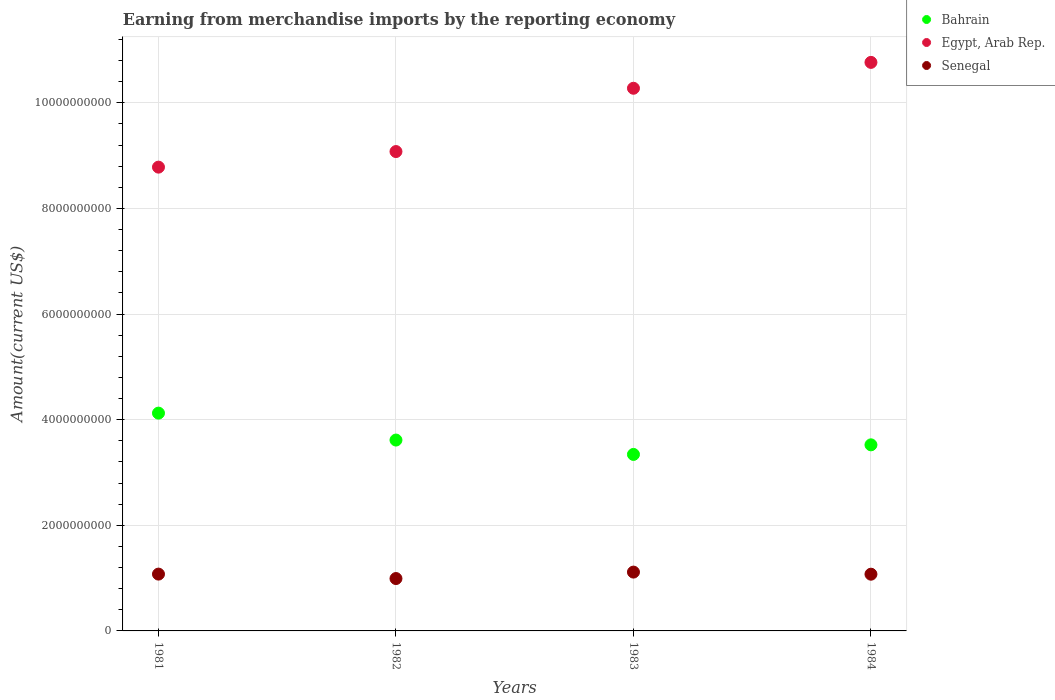Is the number of dotlines equal to the number of legend labels?
Offer a terse response. Yes. What is the amount earned from merchandise imports in Senegal in 1982?
Your answer should be very brief. 9.92e+08. Across all years, what is the maximum amount earned from merchandise imports in Bahrain?
Ensure brevity in your answer.  4.12e+09. Across all years, what is the minimum amount earned from merchandise imports in Egypt, Arab Rep.?
Make the answer very short. 8.78e+09. In which year was the amount earned from merchandise imports in Bahrain maximum?
Make the answer very short. 1981. What is the total amount earned from merchandise imports in Senegal in the graph?
Provide a short and direct response. 4.26e+09. What is the difference between the amount earned from merchandise imports in Egypt, Arab Rep. in 1981 and that in 1983?
Make the answer very short. -1.49e+09. What is the difference between the amount earned from merchandise imports in Bahrain in 1983 and the amount earned from merchandise imports in Senegal in 1982?
Your answer should be compact. 2.35e+09. What is the average amount earned from merchandise imports in Senegal per year?
Offer a very short reply. 1.06e+09. In the year 1983, what is the difference between the amount earned from merchandise imports in Senegal and amount earned from merchandise imports in Egypt, Arab Rep.?
Your answer should be very brief. -9.16e+09. What is the ratio of the amount earned from merchandise imports in Senegal in 1983 to that in 1984?
Your answer should be very brief. 1.04. What is the difference between the highest and the second highest amount earned from merchandise imports in Senegal?
Your response must be concise. 3.80e+07. What is the difference between the highest and the lowest amount earned from merchandise imports in Senegal?
Ensure brevity in your answer.  1.22e+08. In how many years, is the amount earned from merchandise imports in Egypt, Arab Rep. greater than the average amount earned from merchandise imports in Egypt, Arab Rep. taken over all years?
Ensure brevity in your answer.  2. Is the sum of the amount earned from merchandise imports in Egypt, Arab Rep. in 1982 and 1984 greater than the maximum amount earned from merchandise imports in Bahrain across all years?
Your answer should be compact. Yes. Does the amount earned from merchandise imports in Egypt, Arab Rep. monotonically increase over the years?
Give a very brief answer. Yes. Is the amount earned from merchandise imports in Bahrain strictly greater than the amount earned from merchandise imports in Egypt, Arab Rep. over the years?
Your answer should be compact. No. Is the amount earned from merchandise imports in Bahrain strictly less than the amount earned from merchandise imports in Senegal over the years?
Keep it short and to the point. No. How many years are there in the graph?
Give a very brief answer. 4. What is the difference between two consecutive major ticks on the Y-axis?
Your answer should be compact. 2.00e+09. Does the graph contain any zero values?
Your response must be concise. No. How are the legend labels stacked?
Offer a terse response. Vertical. What is the title of the graph?
Your response must be concise. Earning from merchandise imports by the reporting economy. What is the label or title of the Y-axis?
Your response must be concise. Amount(current US$). What is the Amount(current US$) of Bahrain in 1981?
Provide a succinct answer. 4.12e+09. What is the Amount(current US$) in Egypt, Arab Rep. in 1981?
Offer a terse response. 8.78e+09. What is the Amount(current US$) in Senegal in 1981?
Provide a short and direct response. 1.08e+09. What is the Amount(current US$) in Bahrain in 1982?
Provide a succinct answer. 3.61e+09. What is the Amount(current US$) in Egypt, Arab Rep. in 1982?
Ensure brevity in your answer.  9.08e+09. What is the Amount(current US$) of Senegal in 1982?
Offer a terse response. 9.92e+08. What is the Amount(current US$) of Bahrain in 1983?
Keep it short and to the point. 3.34e+09. What is the Amount(current US$) of Egypt, Arab Rep. in 1983?
Provide a short and direct response. 1.03e+1. What is the Amount(current US$) of Senegal in 1983?
Your response must be concise. 1.11e+09. What is the Amount(current US$) in Bahrain in 1984?
Give a very brief answer. 3.52e+09. What is the Amount(current US$) of Egypt, Arab Rep. in 1984?
Ensure brevity in your answer.  1.08e+1. What is the Amount(current US$) in Senegal in 1984?
Ensure brevity in your answer.  1.07e+09. Across all years, what is the maximum Amount(current US$) in Bahrain?
Ensure brevity in your answer.  4.12e+09. Across all years, what is the maximum Amount(current US$) of Egypt, Arab Rep.?
Make the answer very short. 1.08e+1. Across all years, what is the maximum Amount(current US$) in Senegal?
Offer a very short reply. 1.11e+09. Across all years, what is the minimum Amount(current US$) in Bahrain?
Give a very brief answer. 3.34e+09. Across all years, what is the minimum Amount(current US$) in Egypt, Arab Rep.?
Your answer should be compact. 8.78e+09. Across all years, what is the minimum Amount(current US$) of Senegal?
Your answer should be compact. 9.92e+08. What is the total Amount(current US$) of Bahrain in the graph?
Your response must be concise. 1.46e+1. What is the total Amount(current US$) of Egypt, Arab Rep. in the graph?
Offer a terse response. 3.89e+1. What is the total Amount(current US$) of Senegal in the graph?
Make the answer very short. 4.26e+09. What is the difference between the Amount(current US$) of Bahrain in 1981 and that in 1982?
Provide a succinct answer. 5.10e+08. What is the difference between the Amount(current US$) in Egypt, Arab Rep. in 1981 and that in 1982?
Your answer should be compact. -2.95e+08. What is the difference between the Amount(current US$) in Senegal in 1981 and that in 1982?
Offer a terse response. 8.40e+07. What is the difference between the Amount(current US$) of Bahrain in 1981 and that in 1983?
Make the answer very short. 7.82e+08. What is the difference between the Amount(current US$) of Egypt, Arab Rep. in 1981 and that in 1983?
Your answer should be very brief. -1.49e+09. What is the difference between the Amount(current US$) in Senegal in 1981 and that in 1983?
Offer a very short reply. -3.80e+07. What is the difference between the Amount(current US$) in Bahrain in 1981 and that in 1984?
Your response must be concise. 6.00e+08. What is the difference between the Amount(current US$) of Egypt, Arab Rep. in 1981 and that in 1984?
Your response must be concise. -1.98e+09. What is the difference between the Amount(current US$) in Senegal in 1981 and that in 1984?
Your answer should be compact. 1.67e+06. What is the difference between the Amount(current US$) in Bahrain in 1982 and that in 1983?
Make the answer very short. 2.72e+08. What is the difference between the Amount(current US$) of Egypt, Arab Rep. in 1982 and that in 1983?
Your answer should be very brief. -1.20e+09. What is the difference between the Amount(current US$) in Senegal in 1982 and that in 1983?
Give a very brief answer. -1.22e+08. What is the difference between the Amount(current US$) of Bahrain in 1982 and that in 1984?
Offer a terse response. 9.06e+07. What is the difference between the Amount(current US$) in Egypt, Arab Rep. in 1982 and that in 1984?
Offer a terse response. -1.69e+09. What is the difference between the Amount(current US$) in Senegal in 1982 and that in 1984?
Give a very brief answer. -8.23e+07. What is the difference between the Amount(current US$) in Bahrain in 1983 and that in 1984?
Provide a succinct answer. -1.82e+08. What is the difference between the Amount(current US$) of Egypt, Arab Rep. in 1983 and that in 1984?
Provide a short and direct response. -4.90e+08. What is the difference between the Amount(current US$) in Senegal in 1983 and that in 1984?
Your answer should be compact. 3.97e+07. What is the difference between the Amount(current US$) in Bahrain in 1981 and the Amount(current US$) in Egypt, Arab Rep. in 1982?
Provide a short and direct response. -4.95e+09. What is the difference between the Amount(current US$) in Bahrain in 1981 and the Amount(current US$) in Senegal in 1982?
Ensure brevity in your answer.  3.13e+09. What is the difference between the Amount(current US$) of Egypt, Arab Rep. in 1981 and the Amount(current US$) of Senegal in 1982?
Provide a succinct answer. 7.79e+09. What is the difference between the Amount(current US$) of Bahrain in 1981 and the Amount(current US$) of Egypt, Arab Rep. in 1983?
Provide a succinct answer. -6.15e+09. What is the difference between the Amount(current US$) in Bahrain in 1981 and the Amount(current US$) in Senegal in 1983?
Your answer should be very brief. 3.01e+09. What is the difference between the Amount(current US$) of Egypt, Arab Rep. in 1981 and the Amount(current US$) of Senegal in 1983?
Give a very brief answer. 7.67e+09. What is the difference between the Amount(current US$) in Bahrain in 1981 and the Amount(current US$) in Egypt, Arab Rep. in 1984?
Give a very brief answer. -6.64e+09. What is the difference between the Amount(current US$) of Bahrain in 1981 and the Amount(current US$) of Senegal in 1984?
Provide a short and direct response. 3.05e+09. What is the difference between the Amount(current US$) in Egypt, Arab Rep. in 1981 and the Amount(current US$) in Senegal in 1984?
Offer a terse response. 7.71e+09. What is the difference between the Amount(current US$) in Bahrain in 1982 and the Amount(current US$) in Egypt, Arab Rep. in 1983?
Your answer should be compact. -6.66e+09. What is the difference between the Amount(current US$) of Bahrain in 1982 and the Amount(current US$) of Senegal in 1983?
Keep it short and to the point. 2.50e+09. What is the difference between the Amount(current US$) of Egypt, Arab Rep. in 1982 and the Amount(current US$) of Senegal in 1983?
Your answer should be compact. 7.96e+09. What is the difference between the Amount(current US$) of Bahrain in 1982 and the Amount(current US$) of Egypt, Arab Rep. in 1984?
Offer a very short reply. -7.15e+09. What is the difference between the Amount(current US$) of Bahrain in 1982 and the Amount(current US$) of Senegal in 1984?
Your response must be concise. 2.54e+09. What is the difference between the Amount(current US$) of Egypt, Arab Rep. in 1982 and the Amount(current US$) of Senegal in 1984?
Make the answer very short. 8.00e+09. What is the difference between the Amount(current US$) in Bahrain in 1983 and the Amount(current US$) in Egypt, Arab Rep. in 1984?
Your answer should be very brief. -7.42e+09. What is the difference between the Amount(current US$) in Bahrain in 1983 and the Amount(current US$) in Senegal in 1984?
Your response must be concise. 2.27e+09. What is the difference between the Amount(current US$) of Egypt, Arab Rep. in 1983 and the Amount(current US$) of Senegal in 1984?
Offer a terse response. 9.20e+09. What is the average Amount(current US$) of Bahrain per year?
Give a very brief answer. 3.65e+09. What is the average Amount(current US$) of Egypt, Arab Rep. per year?
Give a very brief answer. 9.73e+09. What is the average Amount(current US$) of Senegal per year?
Offer a very short reply. 1.06e+09. In the year 1981, what is the difference between the Amount(current US$) of Bahrain and Amount(current US$) of Egypt, Arab Rep.?
Offer a very short reply. -4.66e+09. In the year 1981, what is the difference between the Amount(current US$) of Bahrain and Amount(current US$) of Senegal?
Offer a very short reply. 3.05e+09. In the year 1981, what is the difference between the Amount(current US$) in Egypt, Arab Rep. and Amount(current US$) in Senegal?
Make the answer very short. 7.71e+09. In the year 1982, what is the difference between the Amount(current US$) in Bahrain and Amount(current US$) in Egypt, Arab Rep.?
Give a very brief answer. -5.46e+09. In the year 1982, what is the difference between the Amount(current US$) of Bahrain and Amount(current US$) of Senegal?
Provide a short and direct response. 2.62e+09. In the year 1982, what is the difference between the Amount(current US$) in Egypt, Arab Rep. and Amount(current US$) in Senegal?
Offer a very short reply. 8.09e+09. In the year 1983, what is the difference between the Amount(current US$) of Bahrain and Amount(current US$) of Egypt, Arab Rep.?
Provide a short and direct response. -6.93e+09. In the year 1983, what is the difference between the Amount(current US$) in Bahrain and Amount(current US$) in Senegal?
Provide a succinct answer. 2.23e+09. In the year 1983, what is the difference between the Amount(current US$) of Egypt, Arab Rep. and Amount(current US$) of Senegal?
Your response must be concise. 9.16e+09. In the year 1984, what is the difference between the Amount(current US$) of Bahrain and Amount(current US$) of Egypt, Arab Rep.?
Offer a terse response. -7.24e+09. In the year 1984, what is the difference between the Amount(current US$) in Bahrain and Amount(current US$) in Senegal?
Offer a very short reply. 2.45e+09. In the year 1984, what is the difference between the Amount(current US$) of Egypt, Arab Rep. and Amount(current US$) of Senegal?
Provide a succinct answer. 9.69e+09. What is the ratio of the Amount(current US$) in Bahrain in 1981 to that in 1982?
Offer a terse response. 1.14. What is the ratio of the Amount(current US$) of Egypt, Arab Rep. in 1981 to that in 1982?
Your response must be concise. 0.97. What is the ratio of the Amount(current US$) in Senegal in 1981 to that in 1982?
Make the answer very short. 1.08. What is the ratio of the Amount(current US$) in Bahrain in 1981 to that in 1983?
Ensure brevity in your answer.  1.23. What is the ratio of the Amount(current US$) of Egypt, Arab Rep. in 1981 to that in 1983?
Keep it short and to the point. 0.85. What is the ratio of the Amount(current US$) in Senegal in 1981 to that in 1983?
Your answer should be very brief. 0.97. What is the ratio of the Amount(current US$) of Bahrain in 1981 to that in 1984?
Keep it short and to the point. 1.17. What is the ratio of the Amount(current US$) of Egypt, Arab Rep. in 1981 to that in 1984?
Ensure brevity in your answer.  0.82. What is the ratio of the Amount(current US$) in Bahrain in 1982 to that in 1983?
Your answer should be very brief. 1.08. What is the ratio of the Amount(current US$) of Egypt, Arab Rep. in 1982 to that in 1983?
Your response must be concise. 0.88. What is the ratio of the Amount(current US$) in Senegal in 1982 to that in 1983?
Your response must be concise. 0.89. What is the ratio of the Amount(current US$) of Bahrain in 1982 to that in 1984?
Give a very brief answer. 1.03. What is the ratio of the Amount(current US$) of Egypt, Arab Rep. in 1982 to that in 1984?
Your answer should be compact. 0.84. What is the ratio of the Amount(current US$) of Senegal in 1982 to that in 1984?
Provide a short and direct response. 0.92. What is the ratio of the Amount(current US$) in Bahrain in 1983 to that in 1984?
Offer a terse response. 0.95. What is the ratio of the Amount(current US$) in Egypt, Arab Rep. in 1983 to that in 1984?
Keep it short and to the point. 0.95. What is the difference between the highest and the second highest Amount(current US$) of Bahrain?
Your answer should be compact. 5.10e+08. What is the difference between the highest and the second highest Amount(current US$) in Egypt, Arab Rep.?
Keep it short and to the point. 4.90e+08. What is the difference between the highest and the second highest Amount(current US$) in Senegal?
Keep it short and to the point. 3.80e+07. What is the difference between the highest and the lowest Amount(current US$) in Bahrain?
Your answer should be compact. 7.82e+08. What is the difference between the highest and the lowest Amount(current US$) in Egypt, Arab Rep.?
Offer a very short reply. 1.98e+09. What is the difference between the highest and the lowest Amount(current US$) in Senegal?
Offer a very short reply. 1.22e+08. 